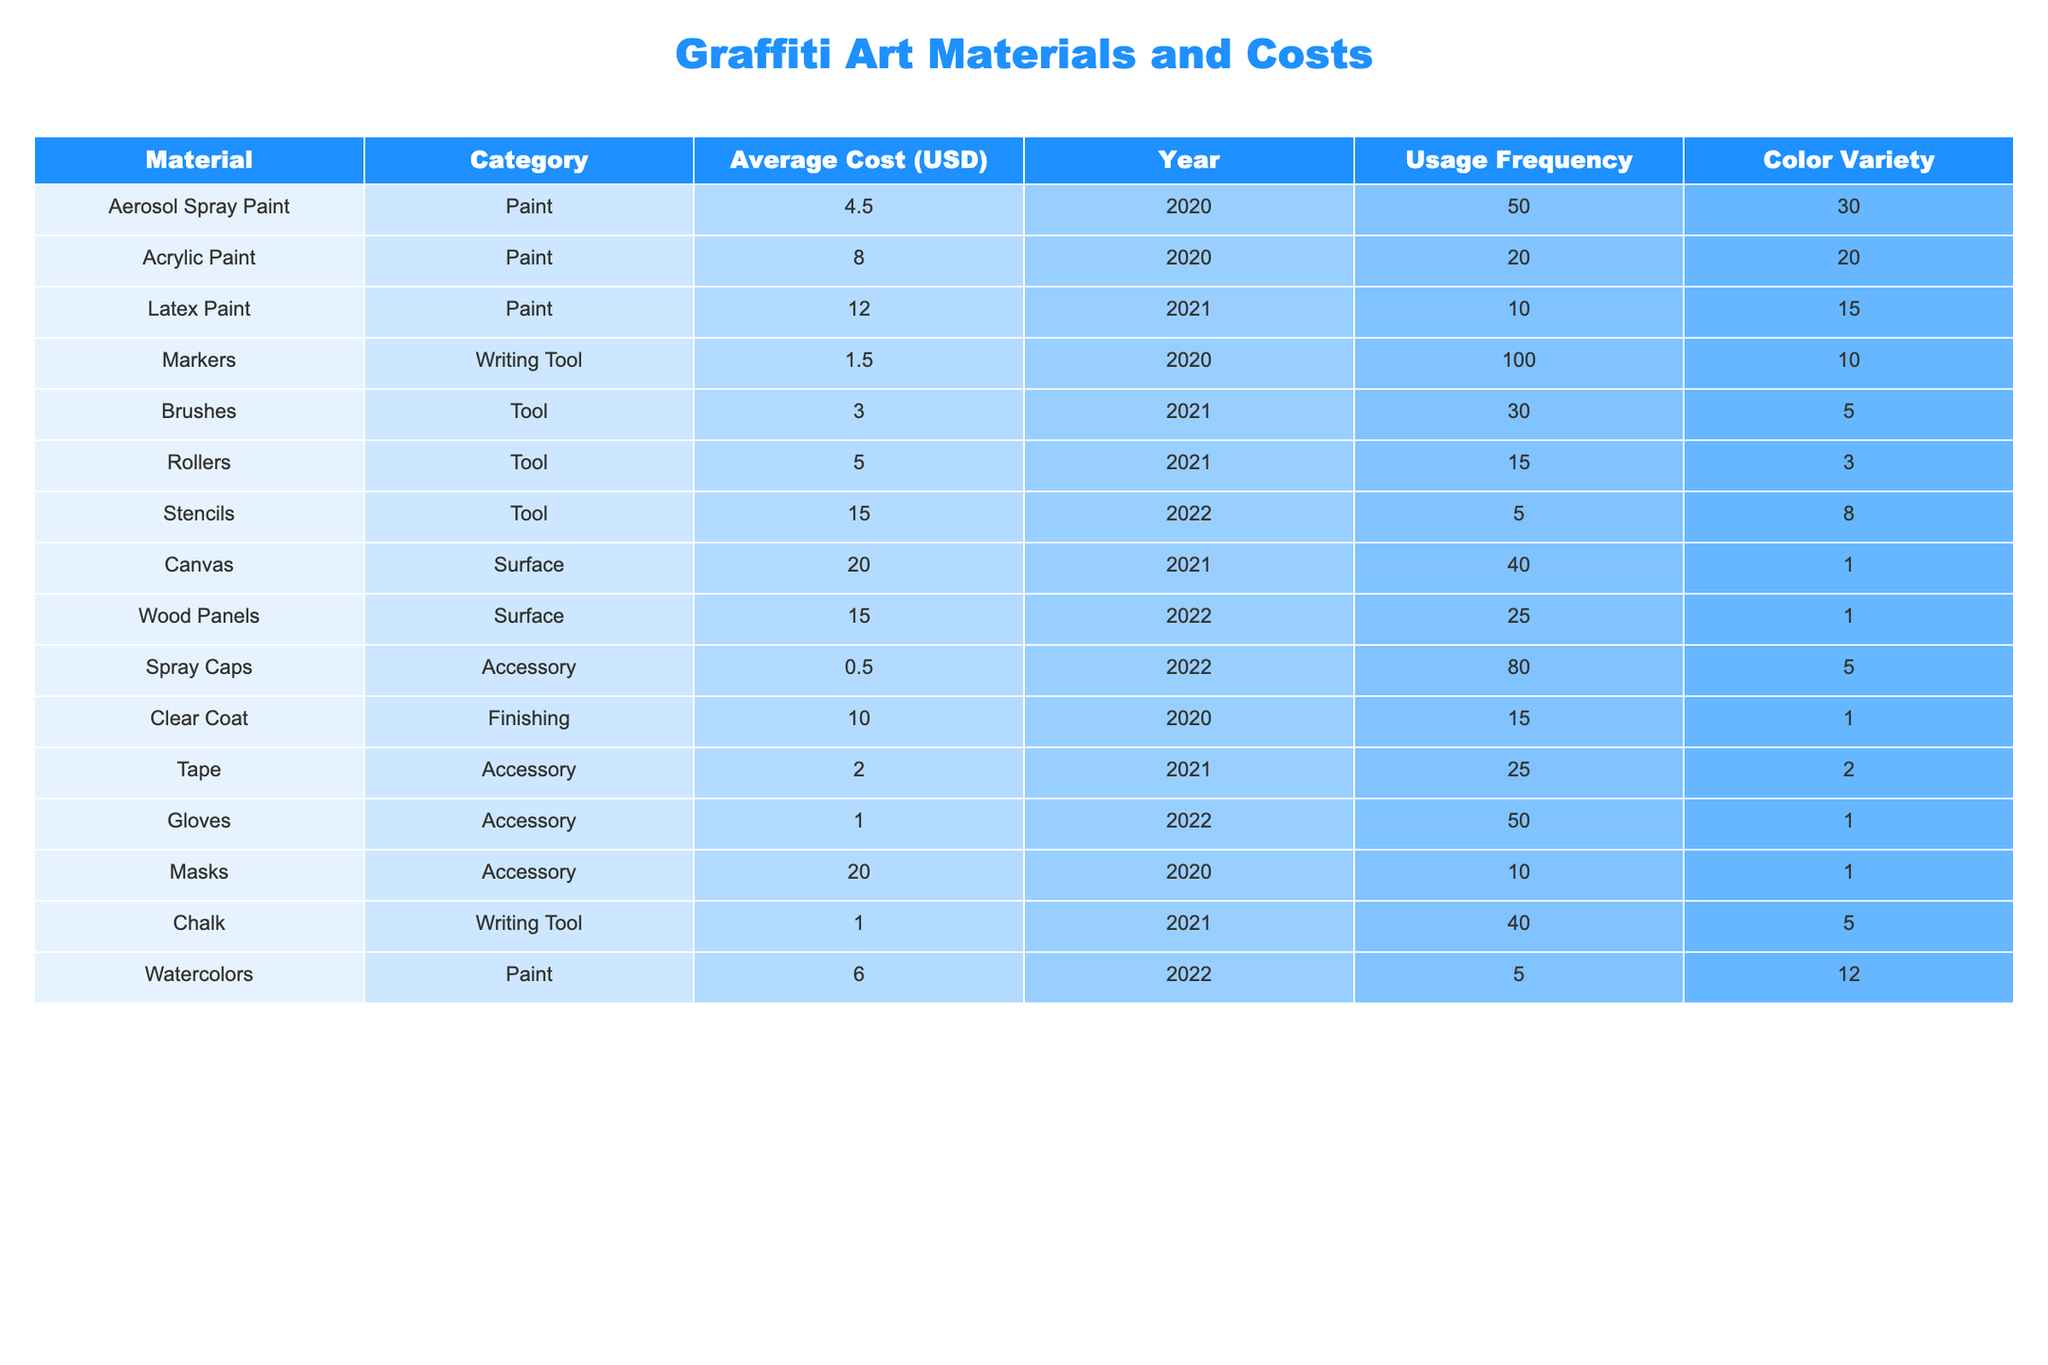What is the average cost of aerosol spray paint in 2020? The average cost is listed directly in the table under the "Average Cost (USD)" column for aerosol spray paint in the year 2020, which is 4.50 USD.
Answer: 4.50 USD How many color varieties are available for stencils in 2022? The color variety for stencils in the year 2022 is recorded in the "Color Variety" column, which shows a value of 8.
Answer: 8 What material has the highest average cost in 2020? By examining the "Average Cost (USD)" column for the year 2020, the highest average cost is associated with masks, which are priced at 20.00 USD.
Answer: Masks What is the total usage frequency of all writing tools across all years? The usage frequencies for writing tools (markers and chalk) are 100 (markers in 2020) and 40 (chalk in 2021). Adding them together gives 100 + 40 = 140.
Answer: 140 Is the average cost of paint materials increasing from 2020 to 2021? The average costs for paint materials in 2020 are 4.50 (aerosol spray paint) and 8.00 (acrylic paint). In 2021, latex paint costs 12.00. Since the average in 2021 (obtained by calculating (4.50 + 8.00 + 12.00) / 3 = 8.83 USD) is higher than 6.25 USD in 2020, the answer is yes.
Answer: Yes Which tool in 2021 is the least frequently used, and what is its usage frequency? In the year 2021, brushes and rollers have the lowest usage frequency from the tools category, with brushes being used 30 times and rollers used 15 times. The least frequently used tool is identified to be rollers with a frequency of 15.
Answer: Rollers, 15 What is the average cost of all accessories used in graffiti art? The average cost for accessories (spray caps, tape, gloves, and masks) is calculated by summing their individual costs: 0.50 + 2.00 + 1.00 + 20.00 = 23.50, then dividing by the count of accessories (4) gives 23.50 / 4 = 5.875.
Answer: 5.88 USD What color variety does the most expensive graffiti material have, and what is that material? The most expensive material identified is masks (20.00 USD), which has 1 color variety listed in the table.
Answer: Masks, 1 color variety How much more frequently are markers used compared to watercolors in 2022? Markers have a usage frequency of 100, and watercolors have a frequency of 5. Subtracting gives 100 - 5 = 95.
Answer: 95 Are there any tools used frequently in 2022? The tools listed have usage frequency data of 5 (stencils), 30 (brushes), and 15 (rollers). The highest frequency in 2022 is stencils, and since their value is low compared to others, no tools can be considered highly frequent.
Answer: No Which surface material has the lowest average cost in 2021? The surfaces in 2021 include canvas (20.00 USD), and wood panels (15.00 USD) listed under the "Average Cost (USD)" column, where wood panels have the lowest cost.
Answer: Wood panels, 15.00 USD 